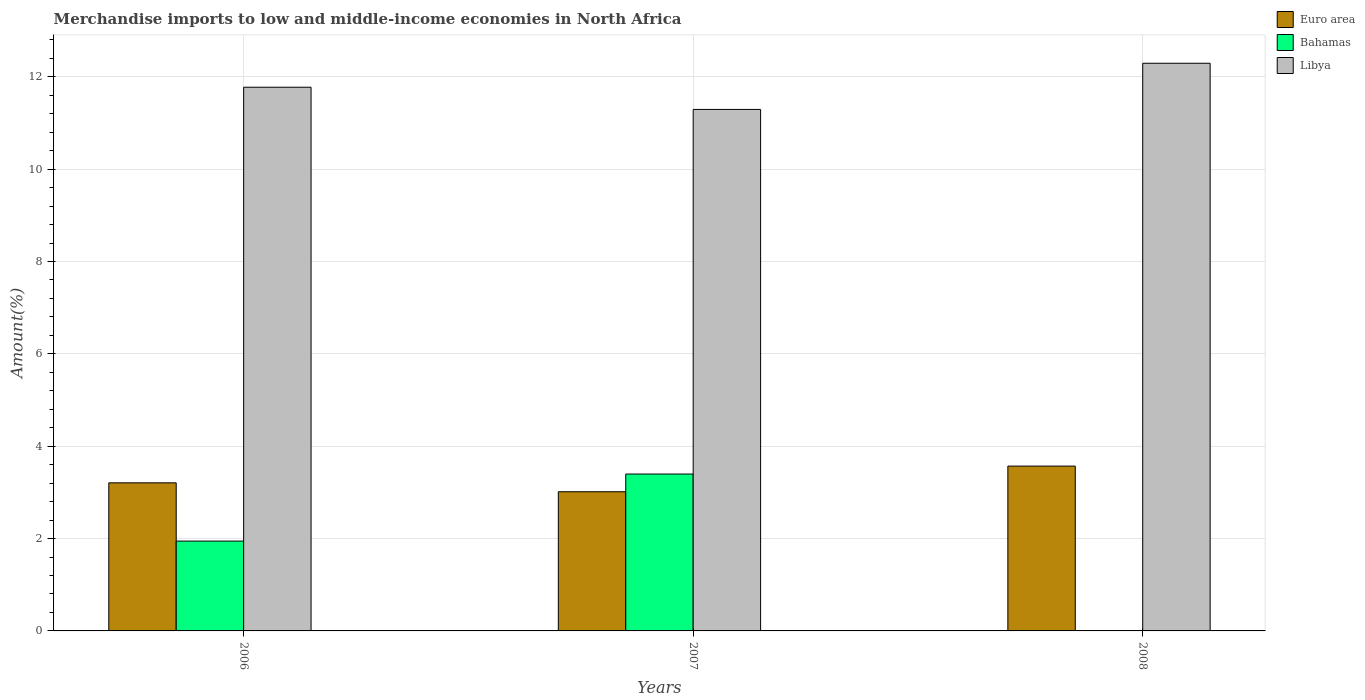Are the number of bars per tick equal to the number of legend labels?
Offer a terse response. Yes. How many bars are there on the 1st tick from the left?
Offer a very short reply. 3. What is the label of the 3rd group of bars from the left?
Provide a succinct answer. 2008. In how many cases, is the number of bars for a given year not equal to the number of legend labels?
Your response must be concise. 0. What is the percentage of amount earned from merchandise imports in Bahamas in 2007?
Keep it short and to the point. 3.4. Across all years, what is the maximum percentage of amount earned from merchandise imports in Libya?
Your answer should be very brief. 12.29. Across all years, what is the minimum percentage of amount earned from merchandise imports in Libya?
Offer a very short reply. 11.29. What is the total percentage of amount earned from merchandise imports in Bahamas in the graph?
Provide a succinct answer. 5.35. What is the difference between the percentage of amount earned from merchandise imports in Euro area in 2006 and that in 2008?
Offer a terse response. -0.36. What is the difference between the percentage of amount earned from merchandise imports in Euro area in 2007 and the percentage of amount earned from merchandise imports in Libya in 2008?
Ensure brevity in your answer.  -9.28. What is the average percentage of amount earned from merchandise imports in Euro area per year?
Offer a very short reply. 3.26. In the year 2007, what is the difference between the percentage of amount earned from merchandise imports in Bahamas and percentage of amount earned from merchandise imports in Euro area?
Provide a short and direct response. 0.38. In how many years, is the percentage of amount earned from merchandise imports in Euro area greater than 12 %?
Offer a terse response. 0. What is the ratio of the percentage of amount earned from merchandise imports in Libya in 2007 to that in 2008?
Keep it short and to the point. 0.92. Is the percentage of amount earned from merchandise imports in Bahamas in 2006 less than that in 2008?
Offer a very short reply. No. What is the difference between the highest and the second highest percentage of amount earned from merchandise imports in Euro area?
Your answer should be very brief. 0.36. What is the difference between the highest and the lowest percentage of amount earned from merchandise imports in Libya?
Keep it short and to the point. 1. What does the 1st bar from the left in 2006 represents?
Keep it short and to the point. Euro area. What does the 1st bar from the right in 2008 represents?
Your answer should be very brief. Libya. Are all the bars in the graph horizontal?
Offer a terse response. No. What is the difference between two consecutive major ticks on the Y-axis?
Your answer should be compact. 2. Are the values on the major ticks of Y-axis written in scientific E-notation?
Your answer should be compact. No. Does the graph contain any zero values?
Keep it short and to the point. No. Does the graph contain grids?
Your answer should be very brief. Yes. Where does the legend appear in the graph?
Make the answer very short. Top right. What is the title of the graph?
Ensure brevity in your answer.  Merchandise imports to low and middle-income economies in North Africa. Does "St. Vincent and the Grenadines" appear as one of the legend labels in the graph?
Your answer should be very brief. No. What is the label or title of the X-axis?
Offer a very short reply. Years. What is the label or title of the Y-axis?
Offer a very short reply. Amount(%). What is the Amount(%) in Euro area in 2006?
Your response must be concise. 3.21. What is the Amount(%) of Bahamas in 2006?
Provide a short and direct response. 1.95. What is the Amount(%) in Libya in 2006?
Your response must be concise. 11.77. What is the Amount(%) of Euro area in 2007?
Provide a succinct answer. 3.01. What is the Amount(%) in Bahamas in 2007?
Your response must be concise. 3.4. What is the Amount(%) of Libya in 2007?
Your answer should be very brief. 11.29. What is the Amount(%) in Euro area in 2008?
Your answer should be compact. 3.57. What is the Amount(%) of Bahamas in 2008?
Provide a succinct answer. 0. What is the Amount(%) in Libya in 2008?
Give a very brief answer. 12.29. Across all years, what is the maximum Amount(%) in Euro area?
Keep it short and to the point. 3.57. Across all years, what is the maximum Amount(%) in Bahamas?
Offer a terse response. 3.4. Across all years, what is the maximum Amount(%) of Libya?
Provide a succinct answer. 12.29. Across all years, what is the minimum Amount(%) in Euro area?
Your answer should be very brief. 3.01. Across all years, what is the minimum Amount(%) in Bahamas?
Keep it short and to the point. 0. Across all years, what is the minimum Amount(%) in Libya?
Your answer should be very brief. 11.29. What is the total Amount(%) in Euro area in the graph?
Offer a terse response. 9.79. What is the total Amount(%) in Bahamas in the graph?
Ensure brevity in your answer.  5.35. What is the total Amount(%) in Libya in the graph?
Provide a short and direct response. 35.36. What is the difference between the Amount(%) in Euro area in 2006 and that in 2007?
Your response must be concise. 0.19. What is the difference between the Amount(%) of Bahamas in 2006 and that in 2007?
Offer a terse response. -1.45. What is the difference between the Amount(%) of Libya in 2006 and that in 2007?
Your answer should be compact. 0.48. What is the difference between the Amount(%) in Euro area in 2006 and that in 2008?
Give a very brief answer. -0.36. What is the difference between the Amount(%) in Bahamas in 2006 and that in 2008?
Your answer should be very brief. 1.94. What is the difference between the Amount(%) of Libya in 2006 and that in 2008?
Your response must be concise. -0.52. What is the difference between the Amount(%) of Euro area in 2007 and that in 2008?
Provide a succinct answer. -0.56. What is the difference between the Amount(%) of Bahamas in 2007 and that in 2008?
Ensure brevity in your answer.  3.39. What is the difference between the Amount(%) of Euro area in 2006 and the Amount(%) of Bahamas in 2007?
Your response must be concise. -0.19. What is the difference between the Amount(%) of Euro area in 2006 and the Amount(%) of Libya in 2007?
Offer a very short reply. -8.09. What is the difference between the Amount(%) of Bahamas in 2006 and the Amount(%) of Libya in 2007?
Provide a succinct answer. -9.35. What is the difference between the Amount(%) of Euro area in 2006 and the Amount(%) of Bahamas in 2008?
Offer a terse response. 3.2. What is the difference between the Amount(%) of Euro area in 2006 and the Amount(%) of Libya in 2008?
Your answer should be very brief. -9.09. What is the difference between the Amount(%) of Bahamas in 2006 and the Amount(%) of Libya in 2008?
Your answer should be very brief. -10.35. What is the difference between the Amount(%) of Euro area in 2007 and the Amount(%) of Bahamas in 2008?
Make the answer very short. 3.01. What is the difference between the Amount(%) in Euro area in 2007 and the Amount(%) in Libya in 2008?
Offer a terse response. -9.28. What is the difference between the Amount(%) of Bahamas in 2007 and the Amount(%) of Libya in 2008?
Make the answer very short. -8.9. What is the average Amount(%) of Euro area per year?
Make the answer very short. 3.26. What is the average Amount(%) in Bahamas per year?
Make the answer very short. 1.78. What is the average Amount(%) in Libya per year?
Your answer should be compact. 11.79. In the year 2006, what is the difference between the Amount(%) in Euro area and Amount(%) in Bahamas?
Make the answer very short. 1.26. In the year 2006, what is the difference between the Amount(%) of Euro area and Amount(%) of Libya?
Offer a very short reply. -8.57. In the year 2006, what is the difference between the Amount(%) in Bahamas and Amount(%) in Libya?
Provide a short and direct response. -9.83. In the year 2007, what is the difference between the Amount(%) of Euro area and Amount(%) of Bahamas?
Give a very brief answer. -0.38. In the year 2007, what is the difference between the Amount(%) in Euro area and Amount(%) in Libya?
Your response must be concise. -8.28. In the year 2007, what is the difference between the Amount(%) of Bahamas and Amount(%) of Libya?
Offer a very short reply. -7.9. In the year 2008, what is the difference between the Amount(%) of Euro area and Amount(%) of Bahamas?
Ensure brevity in your answer.  3.57. In the year 2008, what is the difference between the Amount(%) of Euro area and Amount(%) of Libya?
Offer a terse response. -8.72. In the year 2008, what is the difference between the Amount(%) of Bahamas and Amount(%) of Libya?
Offer a terse response. -12.29. What is the ratio of the Amount(%) in Euro area in 2006 to that in 2007?
Provide a short and direct response. 1.06. What is the ratio of the Amount(%) of Bahamas in 2006 to that in 2007?
Offer a very short reply. 0.57. What is the ratio of the Amount(%) in Libya in 2006 to that in 2007?
Keep it short and to the point. 1.04. What is the ratio of the Amount(%) in Euro area in 2006 to that in 2008?
Your answer should be very brief. 0.9. What is the ratio of the Amount(%) in Bahamas in 2006 to that in 2008?
Offer a very short reply. 652.46. What is the ratio of the Amount(%) of Libya in 2006 to that in 2008?
Ensure brevity in your answer.  0.96. What is the ratio of the Amount(%) in Euro area in 2007 to that in 2008?
Your answer should be very brief. 0.84. What is the ratio of the Amount(%) of Bahamas in 2007 to that in 2008?
Your answer should be very brief. 1139.3. What is the ratio of the Amount(%) in Libya in 2007 to that in 2008?
Offer a very short reply. 0.92. What is the difference between the highest and the second highest Amount(%) of Euro area?
Provide a succinct answer. 0.36. What is the difference between the highest and the second highest Amount(%) in Bahamas?
Ensure brevity in your answer.  1.45. What is the difference between the highest and the second highest Amount(%) of Libya?
Provide a succinct answer. 0.52. What is the difference between the highest and the lowest Amount(%) of Euro area?
Offer a very short reply. 0.56. What is the difference between the highest and the lowest Amount(%) of Bahamas?
Give a very brief answer. 3.39. What is the difference between the highest and the lowest Amount(%) of Libya?
Make the answer very short. 1. 